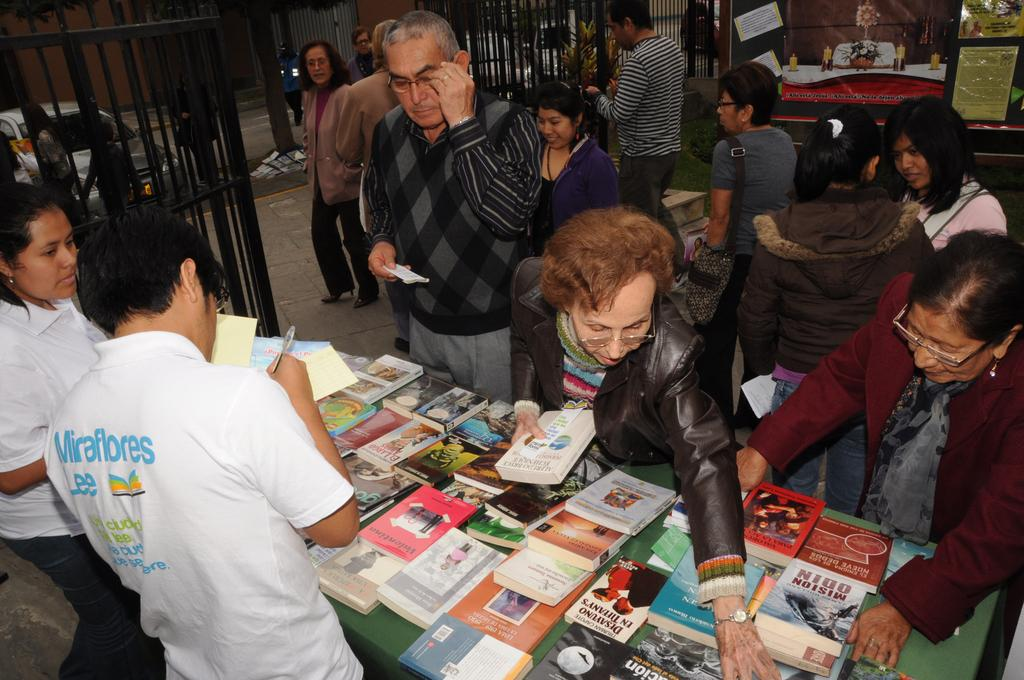<image>
Summarize the visual content of the image. Behind a table loaded with books a man wears a shirt that says Miraflores Lee. 